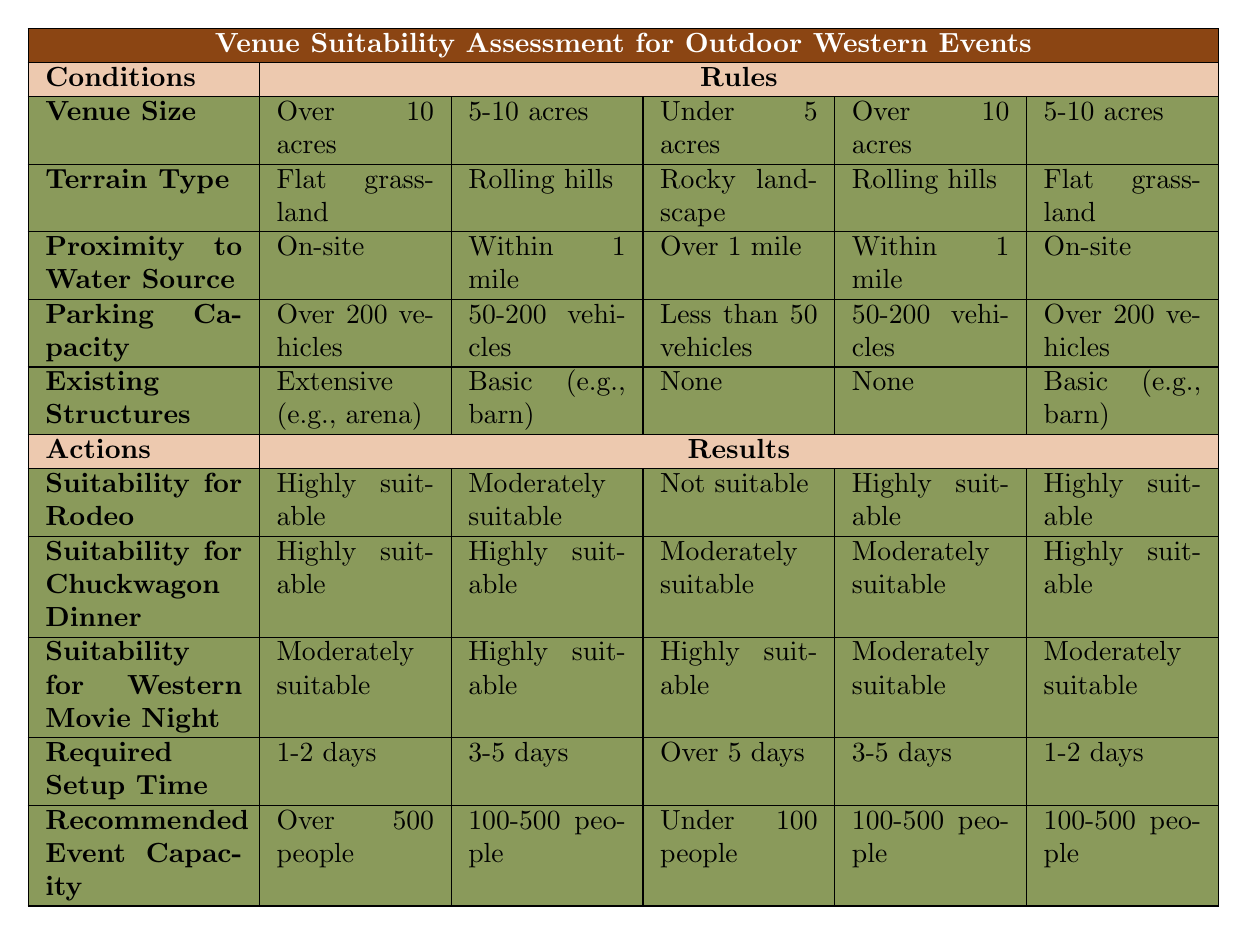What is the recommended event capacity for venues with over 10 acres? Looking at the row for "Over 10 acres", there are multiple outcomes listed. The recommended event capacity in this row shows "Over 500 people" for one set of conditions and "100-500 people" for another. Thus, it's not a single answer but rather varies based on other conditions.
Answer: Over 500 people or 100-500 people Is a venue with a rocky landscape suitable for a chuckwagon dinner? Referring to the row for "Rocky landscape", the result for "Suitability for Chuckwagon Dinner" is listed as "Moderately suitable". Therefore, it is somewhat suitable but not highly.
Answer: Moderately suitable How many venues are highly suitable for rodeos? By checking the "Suitability for Rodeo" and counting the occurrences of "Highly suitable", we find that in the rules provided, there are three instances of "Highly suitable".
Answer: 3 What is the longest required setup time for a venue with less than 50 vehicle parking capacity? Looking at the conditions for "Less than 50 vehicles", the row indicates that the "Required Setup Time" is "Over 5 days". Hence, that's the longest time.
Answer: Over 5 days Can a venue with a basic structure and rolling hills accommodate over 200 vehicle capacity? From the table, the conditions for "Basic (e.g., barn)" and "Rolling hills" lists the parking capacity as "50-200 vehicles". Since "Over 200 vehicles" is not in this circumstance, it cannot accommodate that much.
Answer: No What is the recommended event capacity for venues that have extensive structures and are on-site to a water source? Examining the rows with "Extensive (e.g., arena)" and "On-site" shows the recommended event capacity listed as "Over 500 people". Thus, it accommodates a large crowd.
Answer: Over 500 people Are there any conditions where venues with under 5 acres are highly suitable for the western movie night? When looking at the row corresponding to "Under 5 acres", the suitability for "Western Movie Night" is marked as "Highly suitable". Therefore, it is true.
Answer: Yes What is the average suitability rating for chuckwagon dinners across all conditions? Analyzing the ratings: Highly suitable (3), Moderately suitable (2), and Not suitable (1) gives values 3, 2, 1 with their respective counts: 2, 1, 1. This results in an average of (3*2 + 2*1 + 1*1) / 5 = 2. Thus the average rating is "Moderately suitable".
Answer: Moderately suitable 